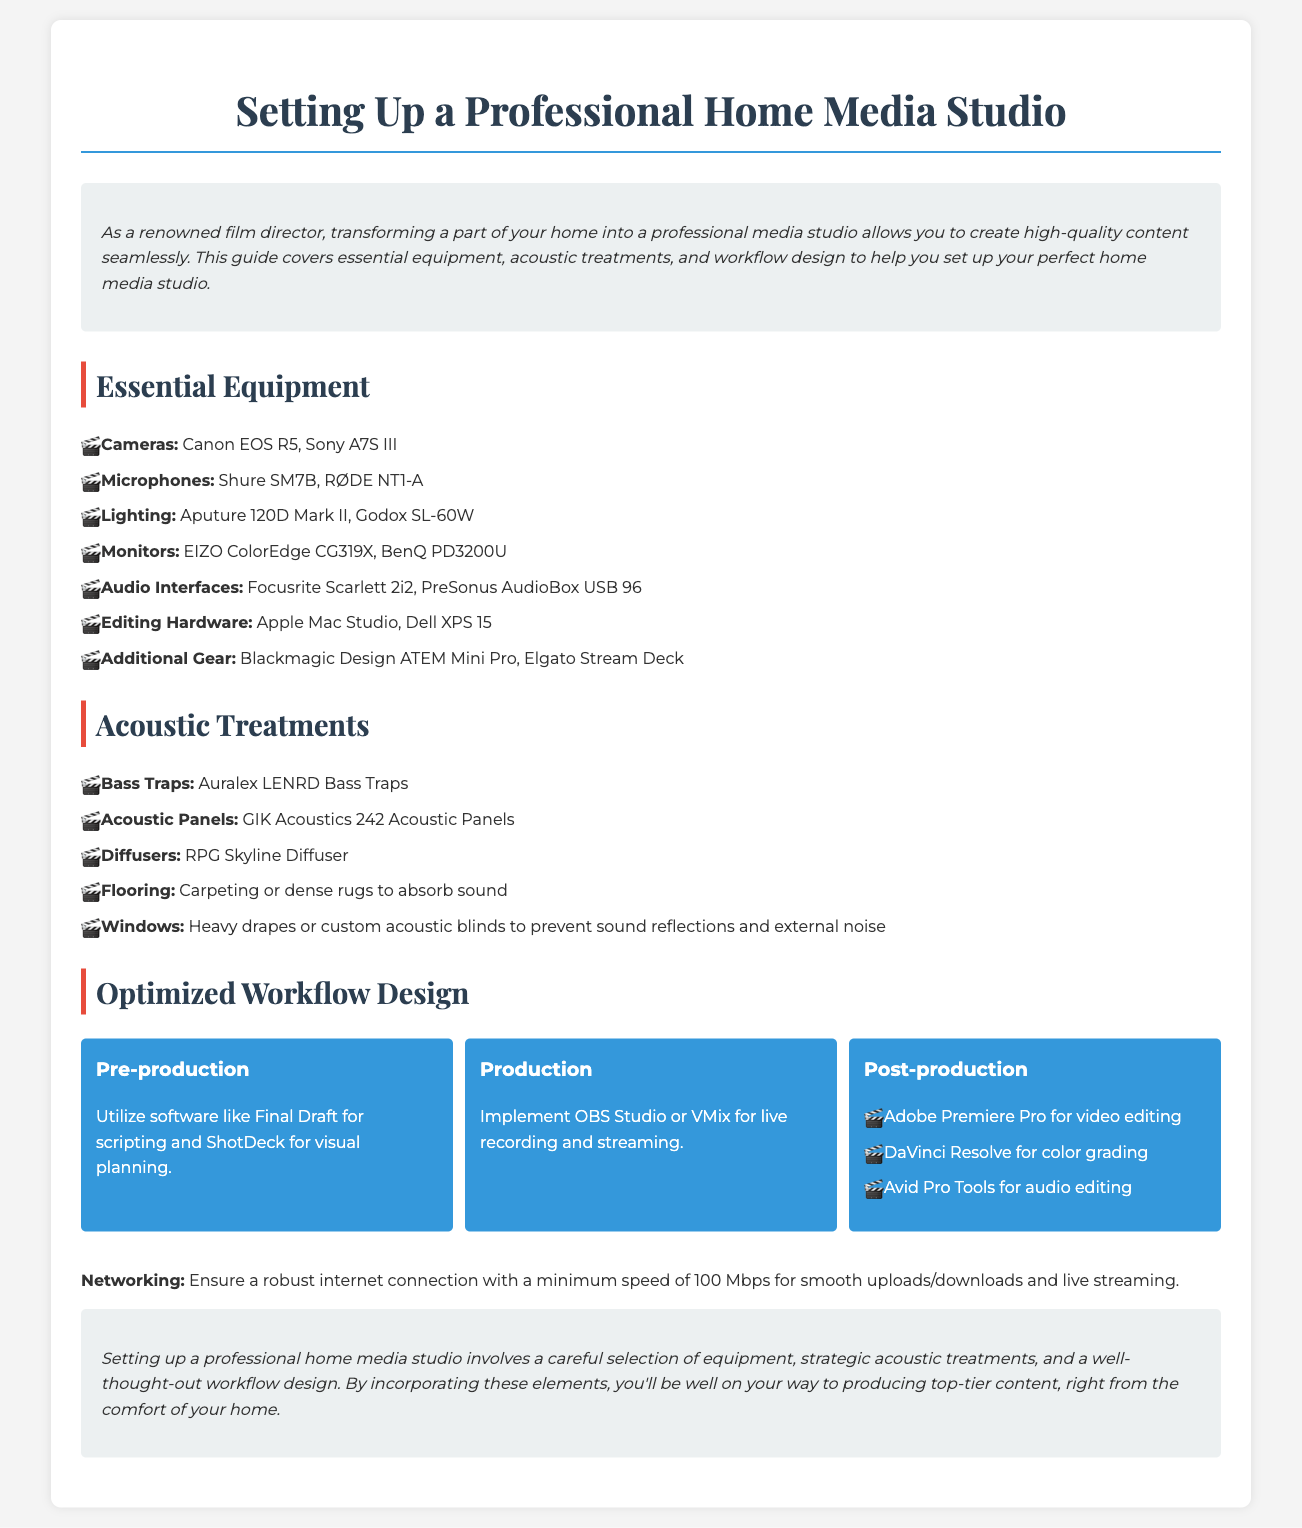What are two recommended cameras? The document lists Canon EOS R5 and Sony A7S III as two recommended cameras.
Answer: Canon EOS R5, Sony A7S III What is a suggested microphone? The document recommends Shure SM7B and RØDE NT1-A as microphones.
Answer: Shure SM7B What is a primary software for post-production video editing? Adobe Premiere Pro is highlighted in the document as the primary software for video editing in post-production.
Answer: Adobe Premiere Pro How many Mbps is the minimum internet speed recommended? The document states that a minimum internet speed of 100 Mbps is recommended for smooth operations.
Answer: 100 Mbps What type of acoustic treatment is suggested for flooring? The document suggests carpeting or dense rugs to absorb sound as a flooring treatment.
Answer: Carpeting or dense rugs Which lighting equipment is mentioned? The document lists Aputure 120D Mark II and Godox SL-60W as examples of lighting equipment.
Answer: Aputure 120D Mark II, Godox SL-60W What does the pre-production workflow suggest using for scripting? The document recommends Final Draft for scripting during pre-production.
Answer: Final Draft What is the main purpose of the introduction section? The introduction section presents the importance of setting up a professional media studio and outlines the content of the guide.
Answer: To introduce the guide on setting up a studio What are acoustic panels mentioned in the document? The document mentions GIK Acoustics 242 Acoustic Panels as an example of acoustic treatment.
Answer: GIK Acoustics 242 Acoustic Panels 